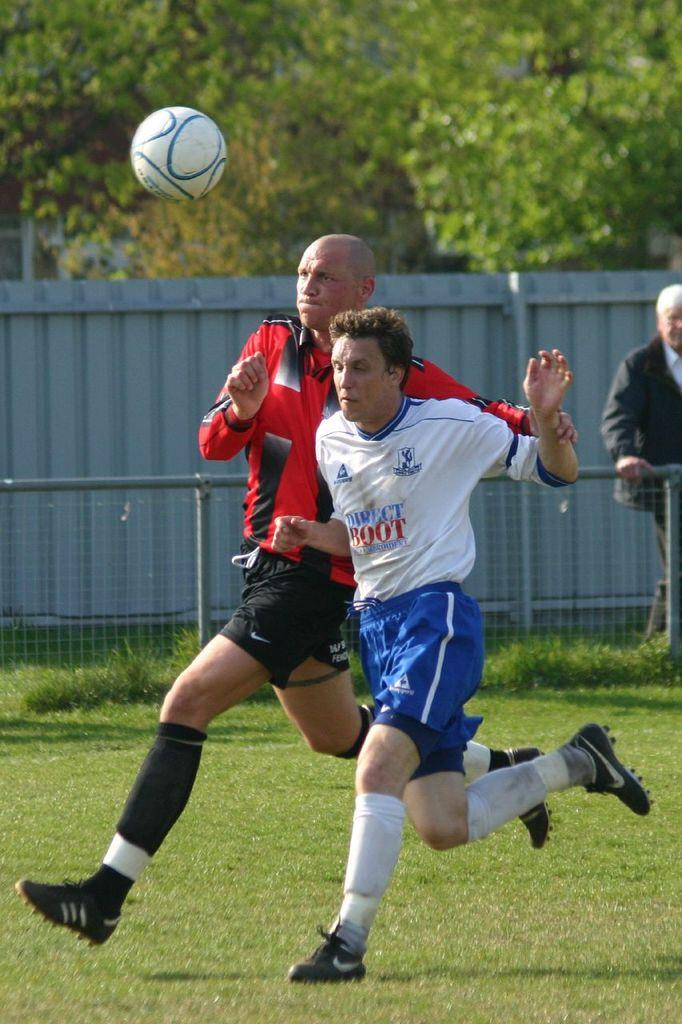What are the two people in the center of the image doing? The two people in the center of the image are playing a game. What object is at the top of the image? There is a ball at the top of the image. What can be seen in the background of the image? There is a mesh, a fence, a man, and trees in the background of the image. What type of surface is at the bottom of the image? There is grass at the bottom of the image. How many books are being read by the fairies in the image? There are no fairies or books present in the image. What color is the lipstick on the man's lips in the image? There is no mention of lipstick or a man's lips in the image. 